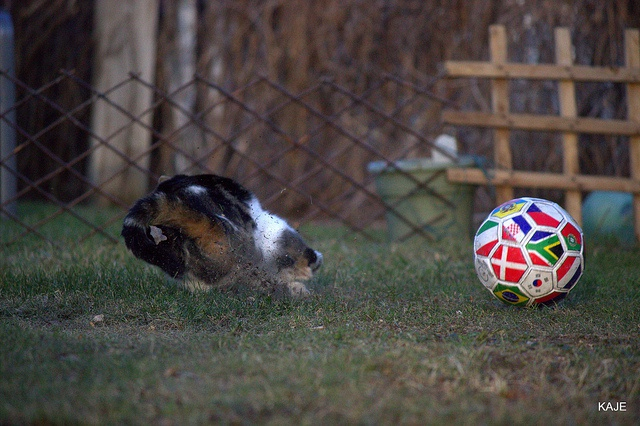Describe the objects in this image and their specific colors. I can see cat in black, gray, and maroon tones, sports ball in black, lavender, darkgray, and brown tones, and sports ball in black, teal, and gray tones in this image. 